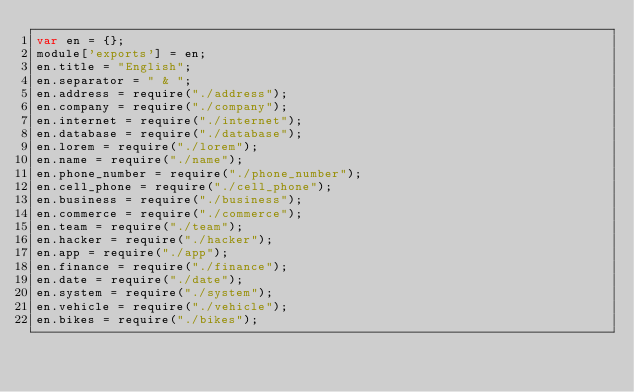Convert code to text. <code><loc_0><loc_0><loc_500><loc_500><_JavaScript_>var en = {};
module['exports'] = en;
en.title = "English";
en.separator = " & ";
en.address = require("./address");
en.company = require("./company");
en.internet = require("./internet");
en.database = require("./database");
en.lorem = require("./lorem");
en.name = require("./name");
en.phone_number = require("./phone_number");
en.cell_phone = require("./cell_phone");
en.business = require("./business");
en.commerce = require("./commerce");
en.team = require("./team");
en.hacker = require("./hacker");
en.app = require("./app");
en.finance = require("./finance");
en.date = require("./date");
en.system = require("./system");
en.vehicle = require("./vehicle");
en.bikes = require("./bikes");
</code> 